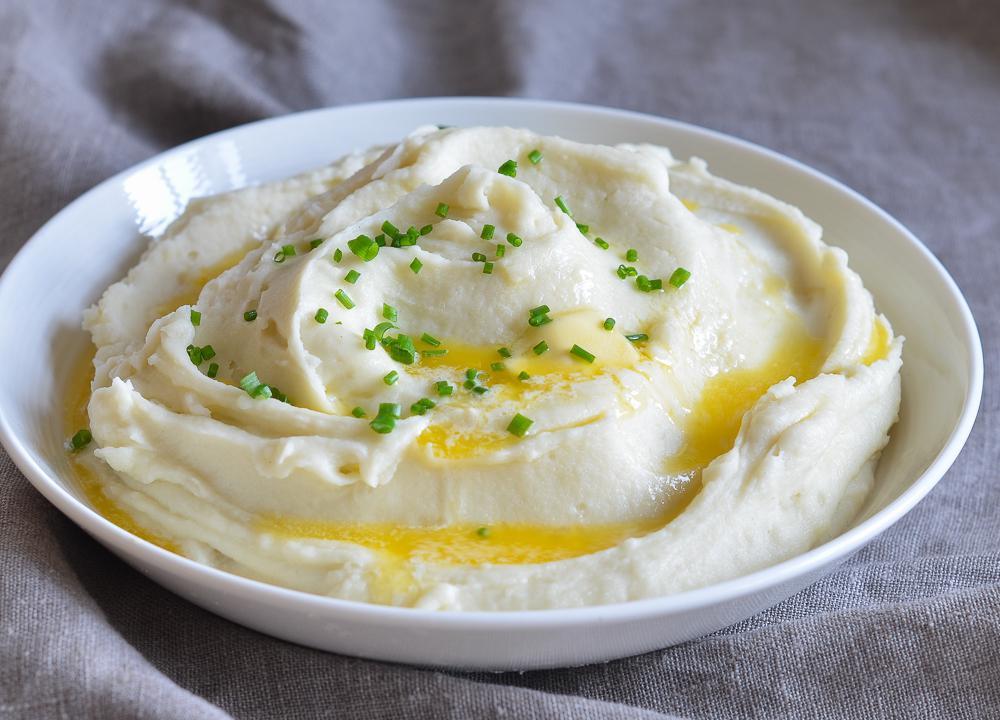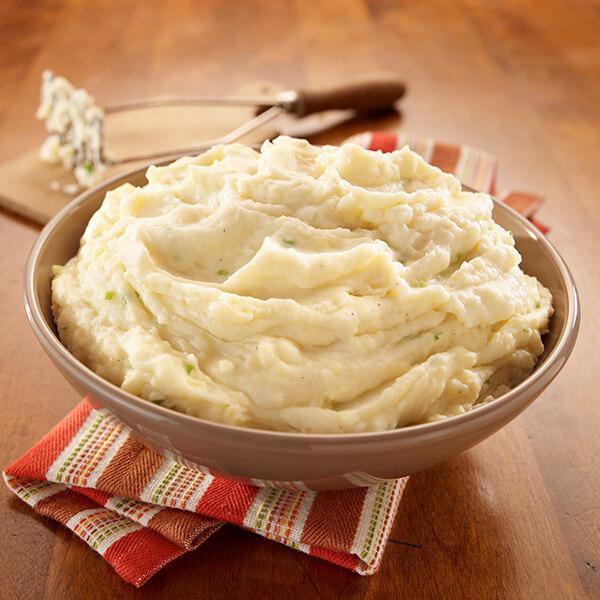The first image is the image on the left, the second image is the image on the right. Analyze the images presented: Is the assertion "One bowl of mashed potatoes has visible pools of melted butter, and the other does not." valid? Answer yes or no. Yes. The first image is the image on the left, the second image is the image on the right. For the images displayed, is the sentence "The left and right image contains the same number of round bowls holding mash potatoes." factually correct? Answer yes or no. Yes. 